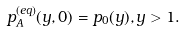Convert formula to latex. <formula><loc_0><loc_0><loc_500><loc_500>p _ { A } ^ { ( e q ) } ( y , 0 ) = p _ { 0 } ( y ) , y > 1 .</formula> 